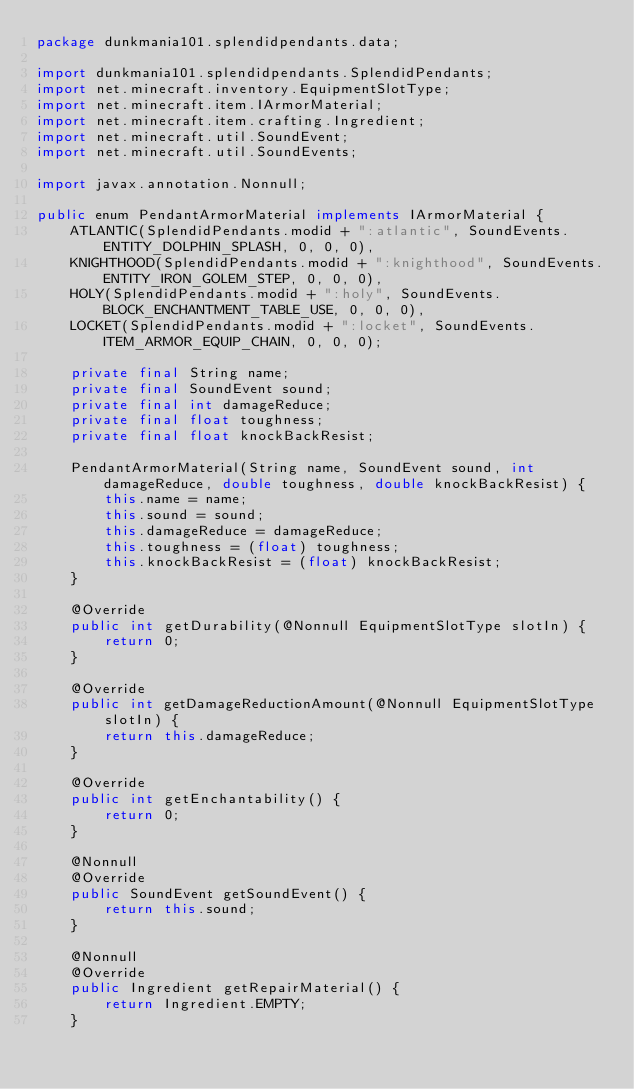Convert code to text. <code><loc_0><loc_0><loc_500><loc_500><_Java_>package dunkmania101.splendidpendants.data;

import dunkmania101.splendidpendants.SplendidPendants;
import net.minecraft.inventory.EquipmentSlotType;
import net.minecraft.item.IArmorMaterial;
import net.minecraft.item.crafting.Ingredient;
import net.minecraft.util.SoundEvent;
import net.minecraft.util.SoundEvents;

import javax.annotation.Nonnull;

public enum PendantArmorMaterial implements IArmorMaterial {
    ATLANTIC(SplendidPendants.modid + ":atlantic", SoundEvents.ENTITY_DOLPHIN_SPLASH, 0, 0, 0),
    KNIGHTHOOD(SplendidPendants.modid + ":knighthood", SoundEvents.ENTITY_IRON_GOLEM_STEP, 0, 0, 0),
    HOLY(SplendidPendants.modid + ":holy", SoundEvents.BLOCK_ENCHANTMENT_TABLE_USE, 0, 0, 0),
    LOCKET(SplendidPendants.modid + ":locket", SoundEvents.ITEM_ARMOR_EQUIP_CHAIN, 0, 0, 0);

    private final String name;
    private final SoundEvent sound;
    private final int damageReduce;
    private final float toughness;
    private final float knockBackResist;

    PendantArmorMaterial(String name, SoundEvent sound, int damageReduce, double toughness, double knockBackResist) {
        this.name = name;
        this.sound = sound;
        this.damageReduce = damageReduce;
        this.toughness = (float) toughness;
        this.knockBackResist = (float) knockBackResist;
    }

    @Override
    public int getDurability(@Nonnull EquipmentSlotType slotIn) {
        return 0;
    }

    @Override
    public int getDamageReductionAmount(@Nonnull EquipmentSlotType slotIn) {
        return this.damageReduce;
    }

    @Override
    public int getEnchantability() {
        return 0;
    }

    @Nonnull
    @Override
    public SoundEvent getSoundEvent() {
        return this.sound;
    }

    @Nonnull
    @Override
    public Ingredient getRepairMaterial() {
        return Ingredient.EMPTY;
    }
</code> 